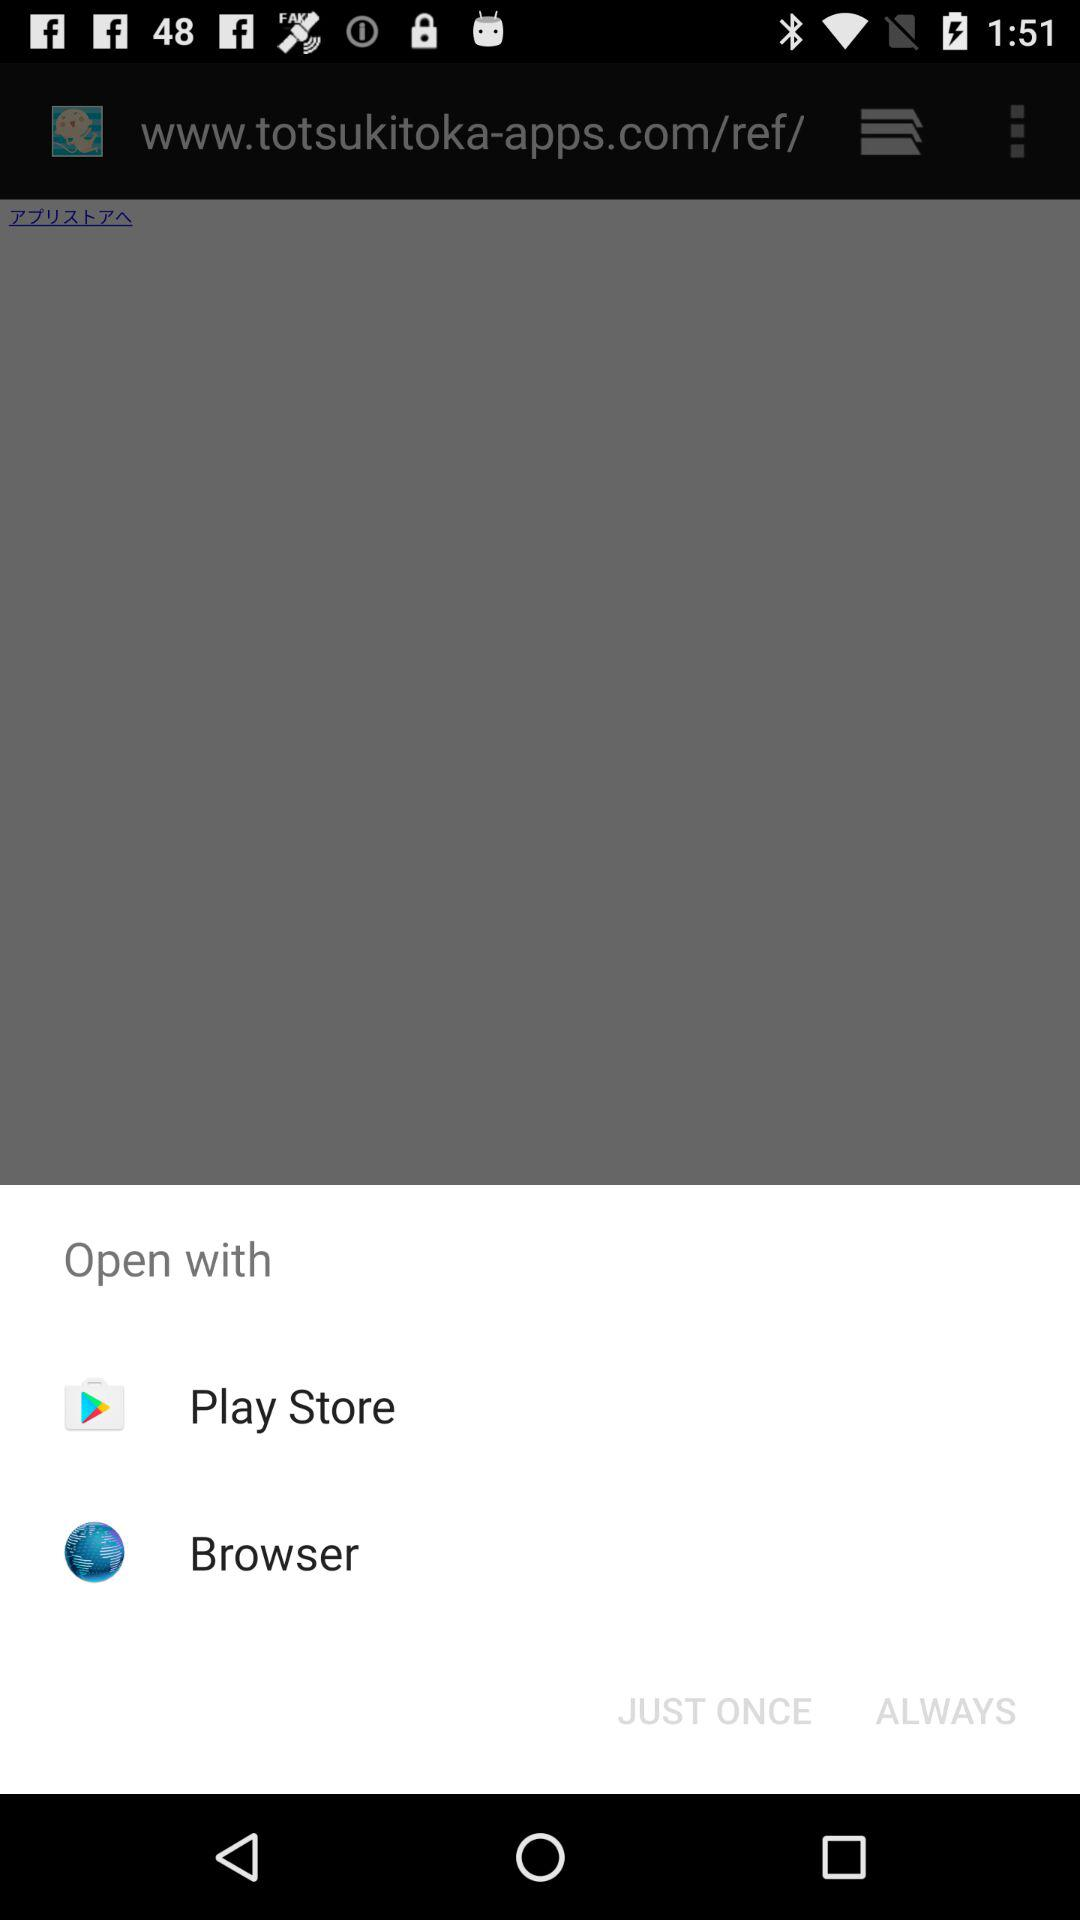Through which applications can we open the content? You can open the content through the "Play Store" and "Browser". 